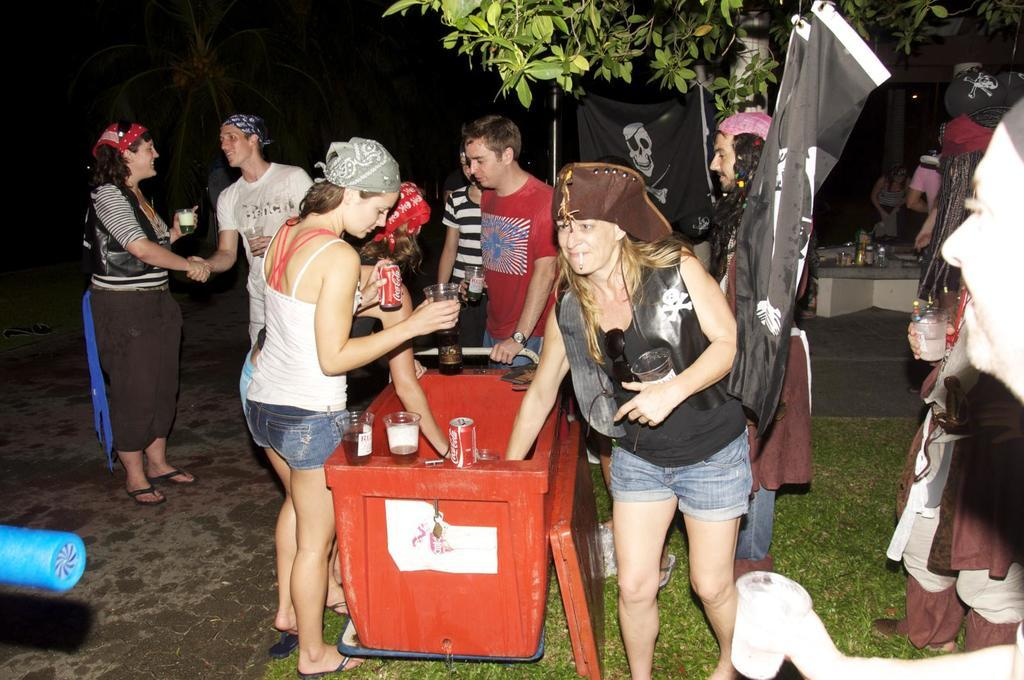How many people are in the image? There is a group of people in the image, but the exact number is not specified. What are the people doing in the image? The people are standing and holding something. What color is the box in the image? There is a red box in the image. What type of vegetation is present in the image? There are trees and grass in the image. What other objects can be seen in the image besides the people and the red box? There are black banners and other objects in the image. How many oranges are being exchanged between the people in the image? There is no mention of oranges or any exchange happening in the image. What is the quality of the air in the image? The image does not provide any information about the air quality. 